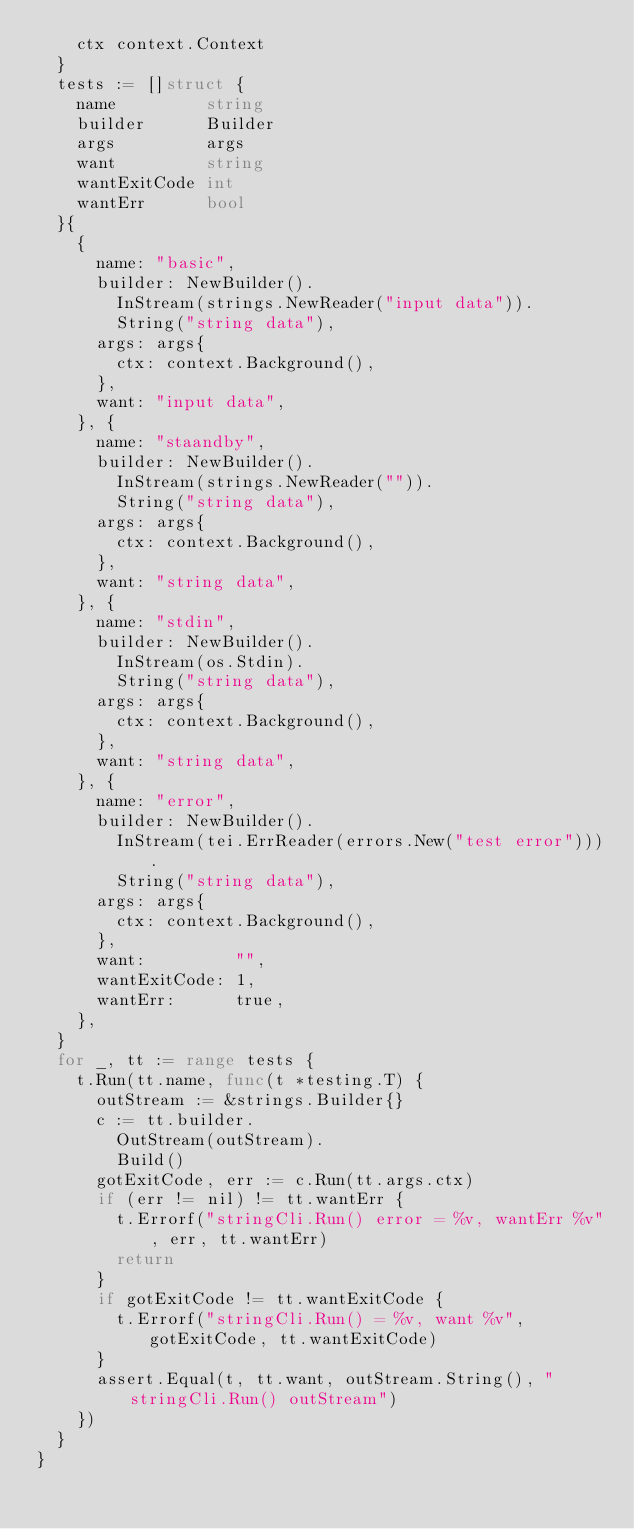Convert code to text. <code><loc_0><loc_0><loc_500><loc_500><_Go_>		ctx context.Context
	}
	tests := []struct {
		name         string
		builder      Builder
		args         args
		want         string
		wantExitCode int
		wantErr      bool
	}{
		{
			name: "basic",
			builder: NewBuilder().
				InStream(strings.NewReader("input data")).
				String("string data"),
			args: args{
				ctx: context.Background(),
			},
			want: "input data",
		}, {
			name: "staandby",
			builder: NewBuilder().
				InStream(strings.NewReader("")).
				String("string data"),
			args: args{
				ctx: context.Background(),
			},
			want: "string data",
		}, {
			name: "stdin",
			builder: NewBuilder().
				InStream(os.Stdin).
				String("string data"),
			args: args{
				ctx: context.Background(),
			},
			want: "string data",
		}, {
			name: "error",
			builder: NewBuilder().
				InStream(tei.ErrReader(errors.New("test error"))).
				String("string data"),
			args: args{
				ctx: context.Background(),
			},
			want:         "",
			wantExitCode: 1,
			wantErr:      true,
		},
	}
	for _, tt := range tests {
		t.Run(tt.name, func(t *testing.T) {
			outStream := &strings.Builder{}
			c := tt.builder.
				OutStream(outStream).
				Build()
			gotExitCode, err := c.Run(tt.args.ctx)
			if (err != nil) != tt.wantErr {
				t.Errorf("stringCli.Run() error = %v, wantErr %v", err, tt.wantErr)
				return
			}
			if gotExitCode != tt.wantExitCode {
				t.Errorf("stringCli.Run() = %v, want %v", gotExitCode, tt.wantExitCode)
			}
			assert.Equal(t, tt.want, outStream.String(), "stringCli.Run() outStream")
		})
	}
}
</code> 